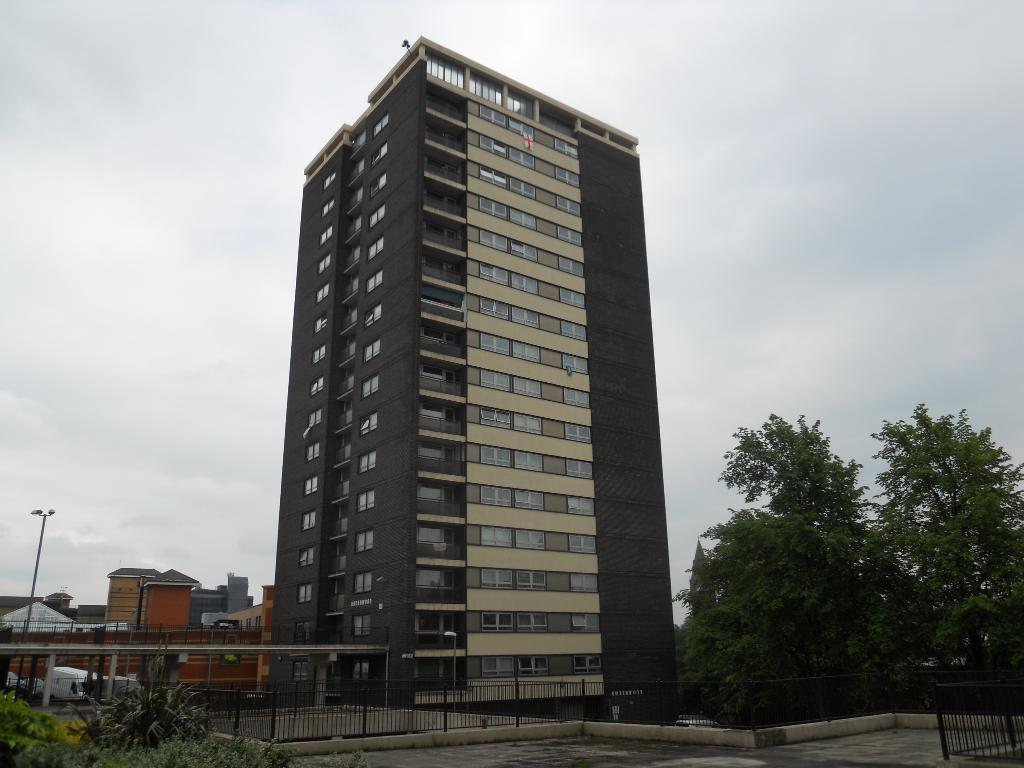What type of vegetation can be seen in the image? There are plants and trees in the image. What type of structure is present in the image? There is a fence in the image. What can be seen in the background of the image? In the background, there are buildings, vehicles, and a pole. What type of fruit is hanging from the trees in the image? There is no fruit visible on the trees in the image. What game is being played by the giraffe in the image? There are no giraffes present in the image, so no game can be observed. 